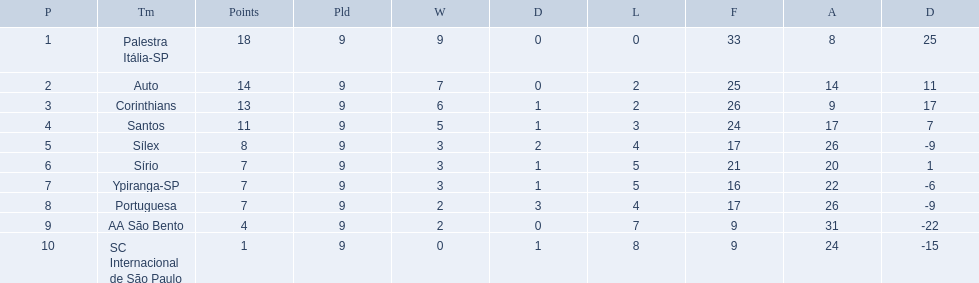What were all the teams that competed in 1926 brazilian football? Palestra Itália-SP, Auto, Corinthians, Santos, Sílex, Sírio, Ypiranga-SP, Portuguesa, AA São Bento, SC Internacional de São Paulo. Which of these had zero games lost? Palestra Itália-SP. What are all the teams? Palestra Itália-SP, Auto, Corinthians, Santos, Sílex, Sírio, Ypiranga-SP, Portuguesa, AA São Bento, SC Internacional de São Paulo. How many times did each team lose? 0, 2, 2, 3, 4, 5, 5, 4, 7, 8. And which team never lost? Palestra Itália-SP. 